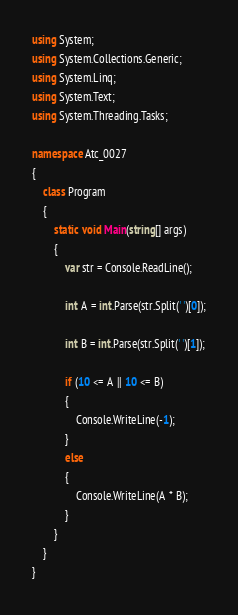Convert code to text. <code><loc_0><loc_0><loc_500><loc_500><_C#_>using System;
using System.Collections.Generic;
using System.Linq;
using System.Text;
using System.Threading.Tasks;

namespace Atc_0027
{
    class Program
    {
        static void Main(string[] args)
        {
            var str = Console.ReadLine();

            int A = int.Parse(str.Split(' ')[0]);

            int B = int.Parse(str.Split(' ')[1]);

            if (10 <= A || 10 <= B)
            {
                Console.WriteLine(-1);
            }
            else
            {
                Console.WriteLine(A * B);
            }
        }
    }
}
</code> 